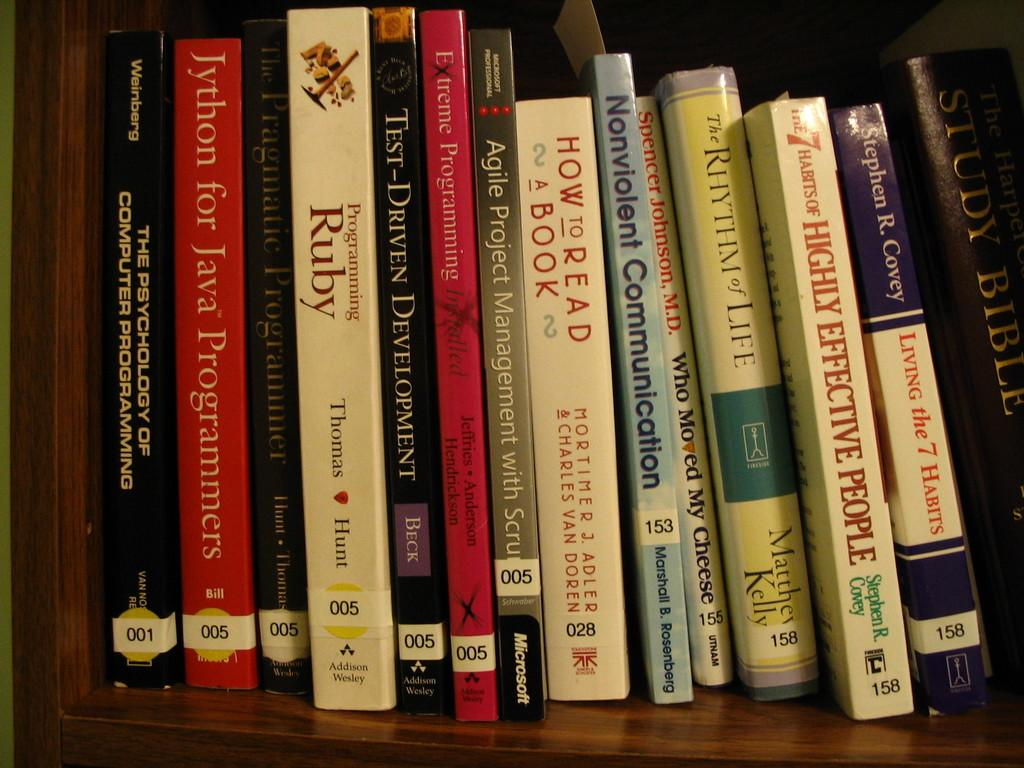Provide a one-sentence caption for the provided image. A group of self help books on a shelf at a library or store which have numbered labels at the bottoms. 